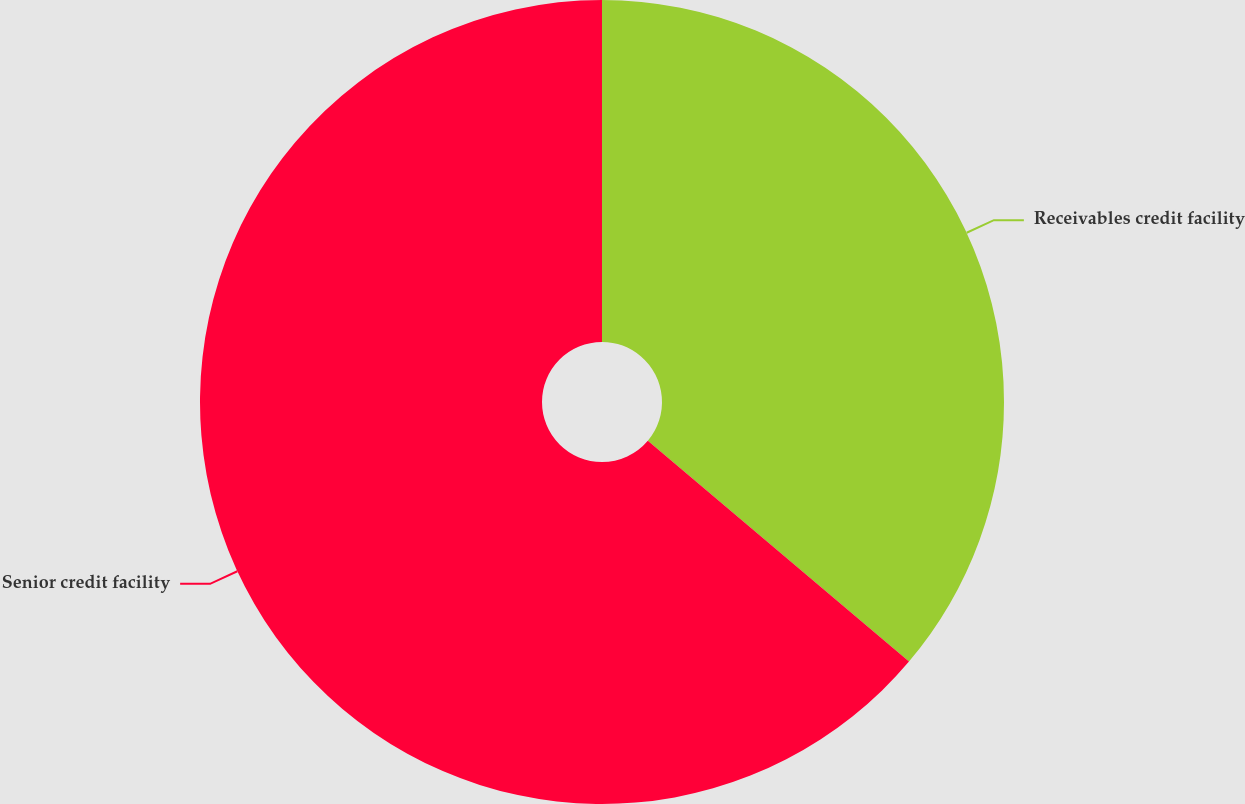Convert chart to OTSL. <chart><loc_0><loc_0><loc_500><loc_500><pie_chart><fcel>Receivables credit facility<fcel>Senior credit facility<nl><fcel>36.17%<fcel>63.83%<nl></chart> 